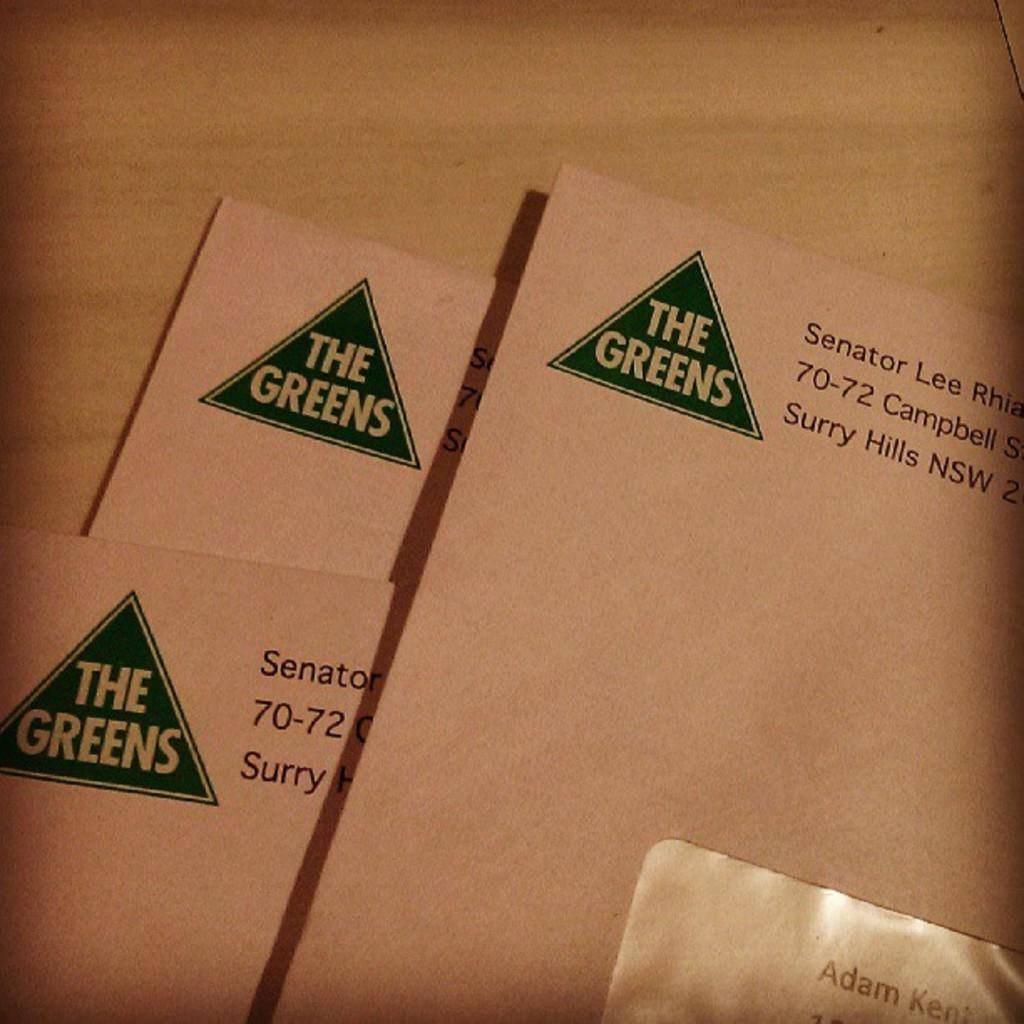Provide a one-sentence caption for the provided image. A letter being sent by The Greens is stacked above other letters. 